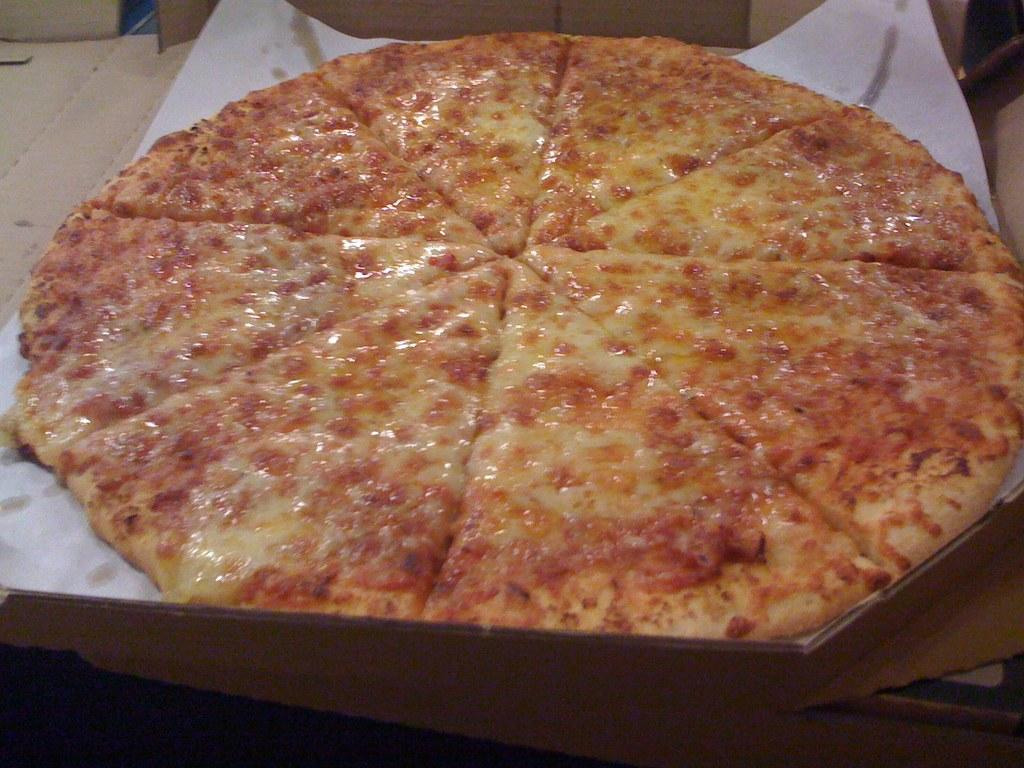What type of food is shown in the image? There is a pizza in the image. What else can be seen in the image besides the pizza? There is a paper in the image. Can you describe the background of the image? There are objects visible in the background of the image. What type of cast can be seen on the pizza in the image? There is no cast present on the pizza in the image. Can you hear the sound of the rock in the image? There is no rock present in the image, so it is not possible to hear any sound related to it. 